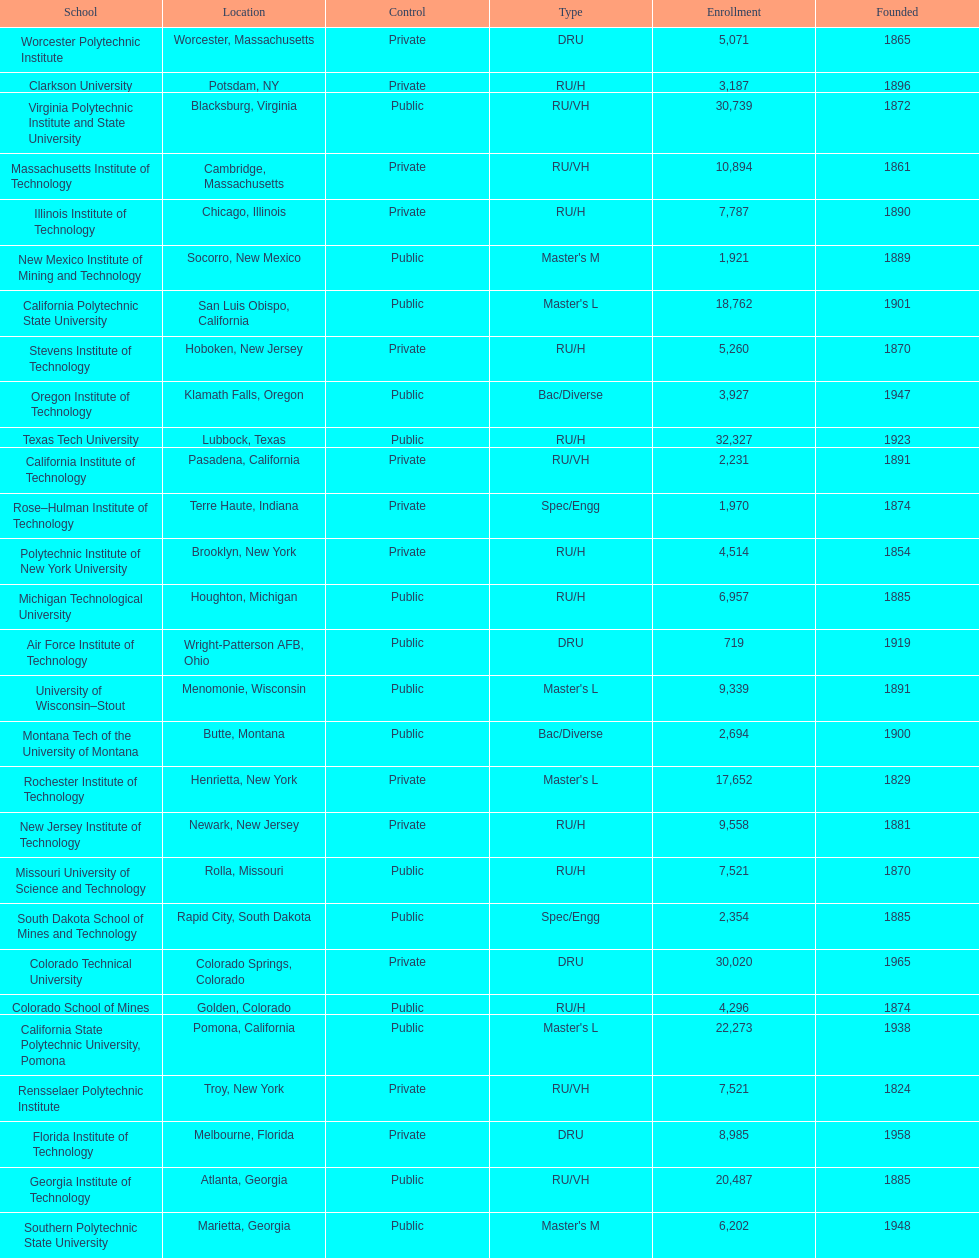Which school had the largest enrollment? Texas Tech University. 